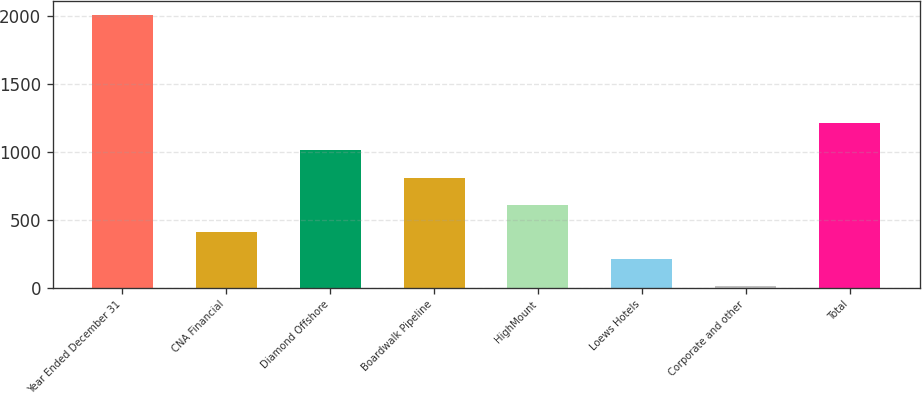Convert chart. <chart><loc_0><loc_0><loc_500><loc_500><bar_chart><fcel>Year Ended December 31<fcel>CNA Financial<fcel>Diamond Offshore<fcel>Boardwalk Pipeline<fcel>HighMount<fcel>Loews Hotels<fcel>Corporate and other<fcel>Total<nl><fcel>2011<fcel>410.2<fcel>1010.5<fcel>810.4<fcel>610.3<fcel>210.1<fcel>10<fcel>1210.6<nl></chart> 